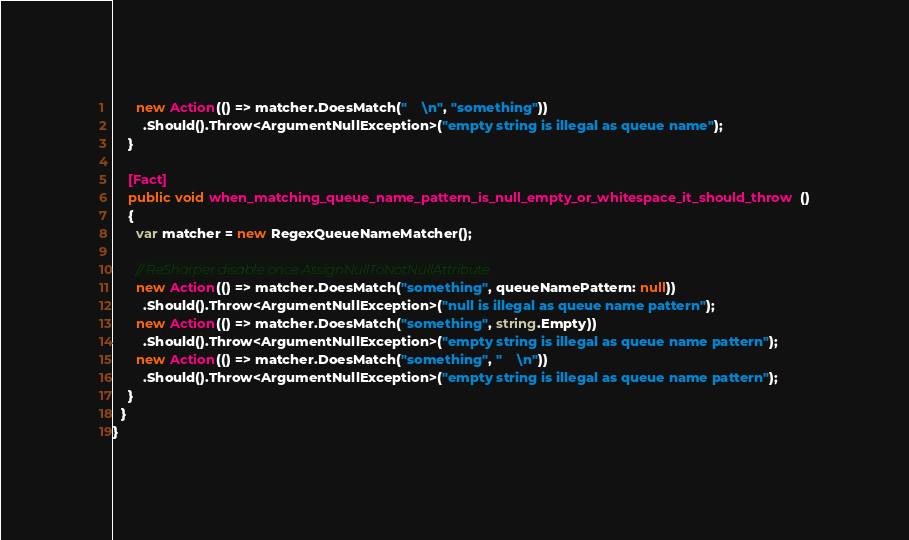<code> <loc_0><loc_0><loc_500><loc_500><_C#_>      new Action(() => matcher.DoesMatch("    \n", "something"))
        .Should().Throw<ArgumentNullException>("empty string is illegal as queue name");
    }

    [Fact]
    public void when_matching_queue_name_pattern_is_null_empty_or_whitespace_it_should_throw()
    {
      var matcher = new RegexQueueNameMatcher();

      // ReSharper disable once AssignNullToNotNullAttribute
      new Action(() => matcher.DoesMatch("something", queueNamePattern: null))
        .Should().Throw<ArgumentNullException>("null is illegal as queue name pattern");
      new Action(() => matcher.DoesMatch("something", string.Empty))
        .Should().Throw<ArgumentNullException>("empty string is illegal as queue name pattern");
      new Action(() => matcher.DoesMatch("something", "    \n"))
        .Should().Throw<ArgumentNullException>("empty string is illegal as queue name pattern");
    }
  }
}
</code> 